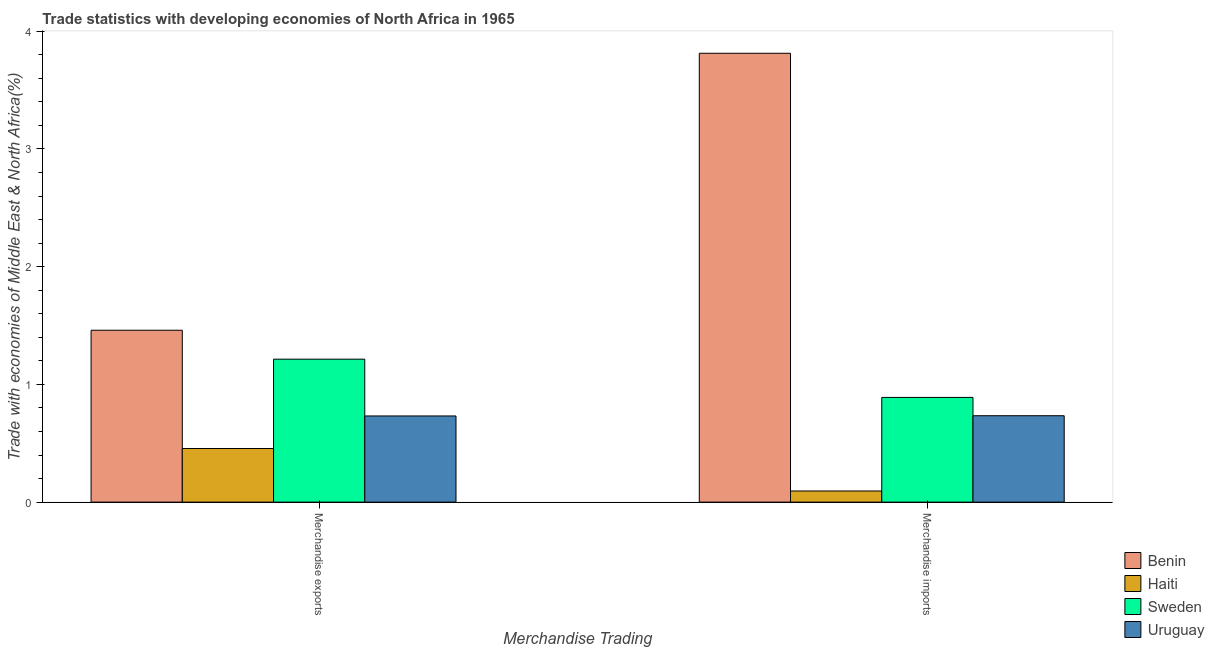Are the number of bars per tick equal to the number of legend labels?
Offer a very short reply. Yes. Are the number of bars on each tick of the X-axis equal?
Give a very brief answer. Yes. How many bars are there on the 2nd tick from the right?
Offer a terse response. 4. What is the merchandise exports in Haiti?
Make the answer very short. 0.46. Across all countries, what is the maximum merchandise imports?
Give a very brief answer. 3.81. Across all countries, what is the minimum merchandise exports?
Give a very brief answer. 0.46. In which country was the merchandise exports maximum?
Ensure brevity in your answer.  Benin. In which country was the merchandise imports minimum?
Provide a succinct answer. Haiti. What is the total merchandise imports in the graph?
Keep it short and to the point. 5.53. What is the difference between the merchandise exports in Haiti and that in Uruguay?
Your response must be concise. -0.28. What is the difference between the merchandise imports in Benin and the merchandise exports in Sweden?
Your answer should be very brief. 2.6. What is the average merchandise imports per country?
Your answer should be compact. 1.38. What is the difference between the merchandise exports and merchandise imports in Uruguay?
Offer a very short reply. -0. What is the ratio of the merchandise imports in Benin to that in Sweden?
Ensure brevity in your answer.  4.29. What does the 3rd bar from the right in Merchandise exports represents?
Make the answer very short. Haiti. Are all the bars in the graph horizontal?
Provide a succinct answer. No. How many countries are there in the graph?
Ensure brevity in your answer.  4. What is the difference between two consecutive major ticks on the Y-axis?
Ensure brevity in your answer.  1. Are the values on the major ticks of Y-axis written in scientific E-notation?
Offer a very short reply. No. Does the graph contain grids?
Your answer should be compact. No. Where does the legend appear in the graph?
Ensure brevity in your answer.  Bottom right. What is the title of the graph?
Your answer should be compact. Trade statistics with developing economies of North Africa in 1965. Does "Uruguay" appear as one of the legend labels in the graph?
Your answer should be compact. Yes. What is the label or title of the X-axis?
Your answer should be very brief. Merchandise Trading. What is the label or title of the Y-axis?
Your answer should be compact. Trade with economies of Middle East & North Africa(%). What is the Trade with economies of Middle East & North Africa(%) of Benin in Merchandise exports?
Provide a short and direct response. 1.46. What is the Trade with economies of Middle East & North Africa(%) in Haiti in Merchandise exports?
Offer a very short reply. 0.46. What is the Trade with economies of Middle East & North Africa(%) in Sweden in Merchandise exports?
Give a very brief answer. 1.21. What is the Trade with economies of Middle East & North Africa(%) in Uruguay in Merchandise exports?
Give a very brief answer. 0.73. What is the Trade with economies of Middle East & North Africa(%) in Benin in Merchandise imports?
Your response must be concise. 3.81. What is the Trade with economies of Middle East & North Africa(%) of Haiti in Merchandise imports?
Make the answer very short. 0.09. What is the Trade with economies of Middle East & North Africa(%) in Sweden in Merchandise imports?
Offer a terse response. 0.89. What is the Trade with economies of Middle East & North Africa(%) of Uruguay in Merchandise imports?
Provide a short and direct response. 0.73. Across all Merchandise Trading, what is the maximum Trade with economies of Middle East & North Africa(%) in Benin?
Offer a terse response. 3.81. Across all Merchandise Trading, what is the maximum Trade with economies of Middle East & North Africa(%) in Haiti?
Offer a terse response. 0.46. Across all Merchandise Trading, what is the maximum Trade with economies of Middle East & North Africa(%) in Sweden?
Keep it short and to the point. 1.21. Across all Merchandise Trading, what is the maximum Trade with economies of Middle East & North Africa(%) in Uruguay?
Provide a short and direct response. 0.73. Across all Merchandise Trading, what is the minimum Trade with economies of Middle East & North Africa(%) in Benin?
Provide a short and direct response. 1.46. Across all Merchandise Trading, what is the minimum Trade with economies of Middle East & North Africa(%) in Haiti?
Give a very brief answer. 0.09. Across all Merchandise Trading, what is the minimum Trade with economies of Middle East & North Africa(%) in Sweden?
Your answer should be very brief. 0.89. Across all Merchandise Trading, what is the minimum Trade with economies of Middle East & North Africa(%) in Uruguay?
Your response must be concise. 0.73. What is the total Trade with economies of Middle East & North Africa(%) in Benin in the graph?
Your answer should be very brief. 5.27. What is the total Trade with economies of Middle East & North Africa(%) of Haiti in the graph?
Provide a short and direct response. 0.55. What is the total Trade with economies of Middle East & North Africa(%) of Sweden in the graph?
Provide a succinct answer. 2.1. What is the total Trade with economies of Middle East & North Africa(%) of Uruguay in the graph?
Offer a very short reply. 1.47. What is the difference between the Trade with economies of Middle East & North Africa(%) of Benin in Merchandise exports and that in Merchandise imports?
Provide a succinct answer. -2.35. What is the difference between the Trade with economies of Middle East & North Africa(%) of Haiti in Merchandise exports and that in Merchandise imports?
Make the answer very short. 0.36. What is the difference between the Trade with economies of Middle East & North Africa(%) of Sweden in Merchandise exports and that in Merchandise imports?
Your answer should be very brief. 0.32. What is the difference between the Trade with economies of Middle East & North Africa(%) of Uruguay in Merchandise exports and that in Merchandise imports?
Offer a very short reply. -0. What is the difference between the Trade with economies of Middle East & North Africa(%) of Benin in Merchandise exports and the Trade with economies of Middle East & North Africa(%) of Haiti in Merchandise imports?
Provide a succinct answer. 1.37. What is the difference between the Trade with economies of Middle East & North Africa(%) in Benin in Merchandise exports and the Trade with economies of Middle East & North Africa(%) in Sweden in Merchandise imports?
Your response must be concise. 0.57. What is the difference between the Trade with economies of Middle East & North Africa(%) in Benin in Merchandise exports and the Trade with economies of Middle East & North Africa(%) in Uruguay in Merchandise imports?
Keep it short and to the point. 0.73. What is the difference between the Trade with economies of Middle East & North Africa(%) of Haiti in Merchandise exports and the Trade with economies of Middle East & North Africa(%) of Sweden in Merchandise imports?
Your response must be concise. -0.43. What is the difference between the Trade with economies of Middle East & North Africa(%) of Haiti in Merchandise exports and the Trade with economies of Middle East & North Africa(%) of Uruguay in Merchandise imports?
Ensure brevity in your answer.  -0.28. What is the difference between the Trade with economies of Middle East & North Africa(%) in Sweden in Merchandise exports and the Trade with economies of Middle East & North Africa(%) in Uruguay in Merchandise imports?
Make the answer very short. 0.48. What is the average Trade with economies of Middle East & North Africa(%) in Benin per Merchandise Trading?
Offer a terse response. 2.64. What is the average Trade with economies of Middle East & North Africa(%) of Haiti per Merchandise Trading?
Offer a terse response. 0.28. What is the average Trade with economies of Middle East & North Africa(%) in Sweden per Merchandise Trading?
Provide a short and direct response. 1.05. What is the average Trade with economies of Middle East & North Africa(%) in Uruguay per Merchandise Trading?
Make the answer very short. 0.73. What is the difference between the Trade with economies of Middle East & North Africa(%) in Benin and Trade with economies of Middle East & North Africa(%) in Haiti in Merchandise exports?
Offer a terse response. 1. What is the difference between the Trade with economies of Middle East & North Africa(%) of Benin and Trade with economies of Middle East & North Africa(%) of Sweden in Merchandise exports?
Give a very brief answer. 0.25. What is the difference between the Trade with economies of Middle East & North Africa(%) of Benin and Trade with economies of Middle East & North Africa(%) of Uruguay in Merchandise exports?
Your answer should be very brief. 0.73. What is the difference between the Trade with economies of Middle East & North Africa(%) in Haiti and Trade with economies of Middle East & North Africa(%) in Sweden in Merchandise exports?
Offer a very short reply. -0.76. What is the difference between the Trade with economies of Middle East & North Africa(%) of Haiti and Trade with economies of Middle East & North Africa(%) of Uruguay in Merchandise exports?
Your answer should be compact. -0.28. What is the difference between the Trade with economies of Middle East & North Africa(%) of Sweden and Trade with economies of Middle East & North Africa(%) of Uruguay in Merchandise exports?
Offer a terse response. 0.48. What is the difference between the Trade with economies of Middle East & North Africa(%) of Benin and Trade with economies of Middle East & North Africa(%) of Haiti in Merchandise imports?
Offer a terse response. 3.72. What is the difference between the Trade with economies of Middle East & North Africa(%) in Benin and Trade with economies of Middle East & North Africa(%) in Sweden in Merchandise imports?
Provide a short and direct response. 2.92. What is the difference between the Trade with economies of Middle East & North Africa(%) of Benin and Trade with economies of Middle East & North Africa(%) of Uruguay in Merchandise imports?
Keep it short and to the point. 3.08. What is the difference between the Trade with economies of Middle East & North Africa(%) in Haiti and Trade with economies of Middle East & North Africa(%) in Sweden in Merchandise imports?
Provide a short and direct response. -0.79. What is the difference between the Trade with economies of Middle East & North Africa(%) in Haiti and Trade with economies of Middle East & North Africa(%) in Uruguay in Merchandise imports?
Your response must be concise. -0.64. What is the difference between the Trade with economies of Middle East & North Africa(%) in Sweden and Trade with economies of Middle East & North Africa(%) in Uruguay in Merchandise imports?
Provide a short and direct response. 0.16. What is the ratio of the Trade with economies of Middle East & North Africa(%) of Benin in Merchandise exports to that in Merchandise imports?
Ensure brevity in your answer.  0.38. What is the ratio of the Trade with economies of Middle East & North Africa(%) of Haiti in Merchandise exports to that in Merchandise imports?
Offer a very short reply. 4.81. What is the ratio of the Trade with economies of Middle East & North Africa(%) of Sweden in Merchandise exports to that in Merchandise imports?
Your response must be concise. 1.37. What is the ratio of the Trade with economies of Middle East & North Africa(%) in Uruguay in Merchandise exports to that in Merchandise imports?
Provide a short and direct response. 1. What is the difference between the highest and the second highest Trade with economies of Middle East & North Africa(%) in Benin?
Give a very brief answer. 2.35. What is the difference between the highest and the second highest Trade with economies of Middle East & North Africa(%) in Haiti?
Offer a terse response. 0.36. What is the difference between the highest and the second highest Trade with economies of Middle East & North Africa(%) in Sweden?
Your response must be concise. 0.32. What is the difference between the highest and the second highest Trade with economies of Middle East & North Africa(%) in Uruguay?
Offer a terse response. 0. What is the difference between the highest and the lowest Trade with economies of Middle East & North Africa(%) of Benin?
Give a very brief answer. 2.35. What is the difference between the highest and the lowest Trade with economies of Middle East & North Africa(%) in Haiti?
Your response must be concise. 0.36. What is the difference between the highest and the lowest Trade with economies of Middle East & North Africa(%) of Sweden?
Your answer should be compact. 0.32. What is the difference between the highest and the lowest Trade with economies of Middle East & North Africa(%) in Uruguay?
Your answer should be very brief. 0. 